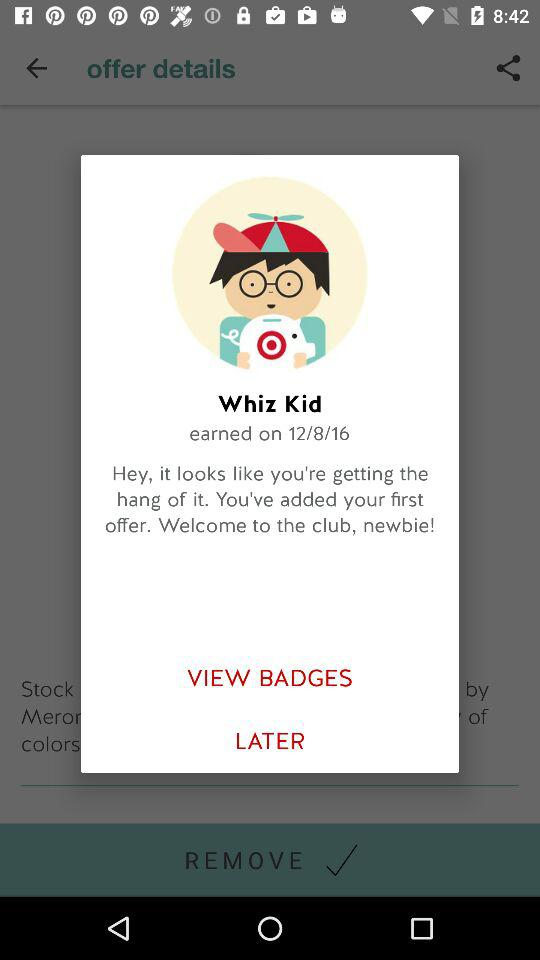How many badges does the user have?
Answer the question using a single word or phrase. 1 